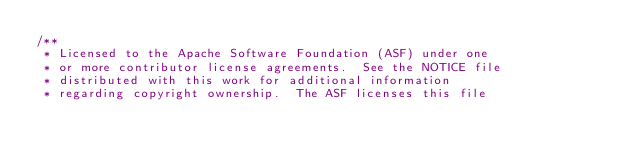<code> <loc_0><loc_0><loc_500><loc_500><_Java_>/**
 * Licensed to the Apache Software Foundation (ASF) under one
 * or more contributor license agreements.  See the NOTICE file
 * distributed with this work for additional information
 * regarding copyright ownership.  The ASF licenses this file</code> 